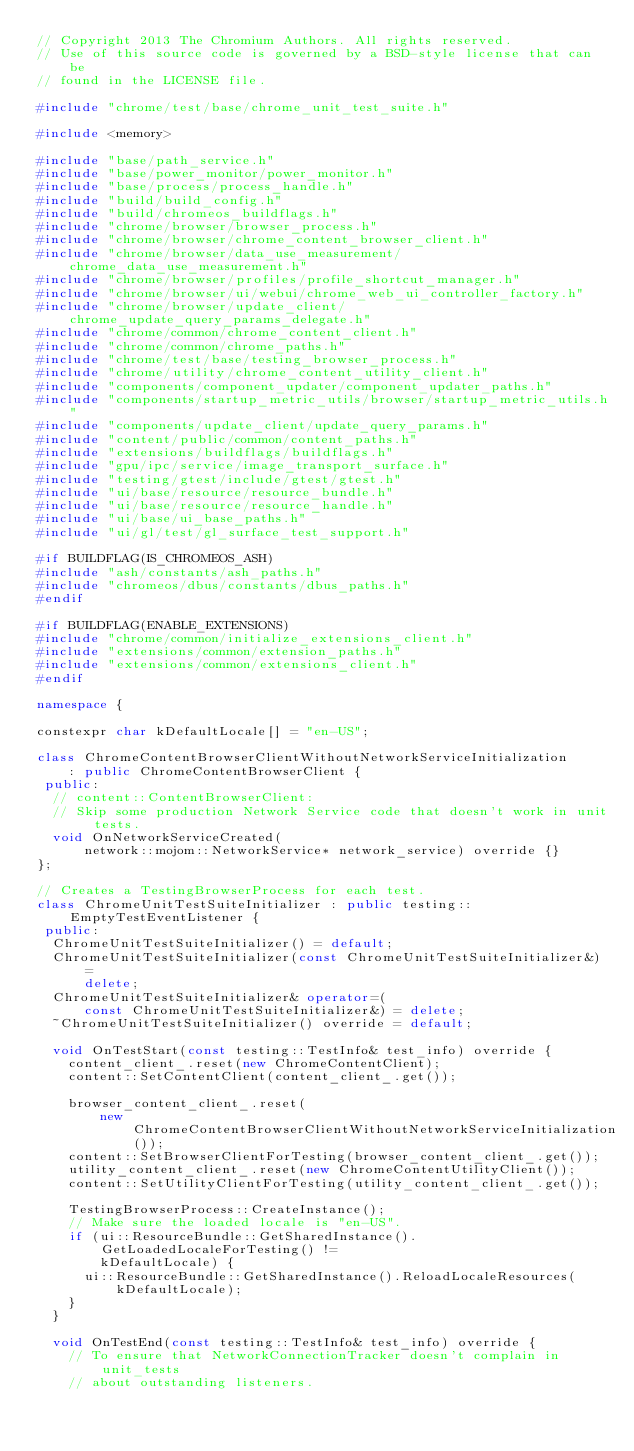Convert code to text. <code><loc_0><loc_0><loc_500><loc_500><_C++_>// Copyright 2013 The Chromium Authors. All rights reserved.
// Use of this source code is governed by a BSD-style license that can be
// found in the LICENSE file.

#include "chrome/test/base/chrome_unit_test_suite.h"

#include <memory>

#include "base/path_service.h"
#include "base/power_monitor/power_monitor.h"
#include "base/process/process_handle.h"
#include "build/build_config.h"
#include "build/chromeos_buildflags.h"
#include "chrome/browser/browser_process.h"
#include "chrome/browser/chrome_content_browser_client.h"
#include "chrome/browser/data_use_measurement/chrome_data_use_measurement.h"
#include "chrome/browser/profiles/profile_shortcut_manager.h"
#include "chrome/browser/ui/webui/chrome_web_ui_controller_factory.h"
#include "chrome/browser/update_client/chrome_update_query_params_delegate.h"
#include "chrome/common/chrome_content_client.h"
#include "chrome/common/chrome_paths.h"
#include "chrome/test/base/testing_browser_process.h"
#include "chrome/utility/chrome_content_utility_client.h"
#include "components/component_updater/component_updater_paths.h"
#include "components/startup_metric_utils/browser/startup_metric_utils.h"
#include "components/update_client/update_query_params.h"
#include "content/public/common/content_paths.h"
#include "extensions/buildflags/buildflags.h"
#include "gpu/ipc/service/image_transport_surface.h"
#include "testing/gtest/include/gtest/gtest.h"
#include "ui/base/resource/resource_bundle.h"
#include "ui/base/resource/resource_handle.h"
#include "ui/base/ui_base_paths.h"
#include "ui/gl/test/gl_surface_test_support.h"

#if BUILDFLAG(IS_CHROMEOS_ASH)
#include "ash/constants/ash_paths.h"
#include "chromeos/dbus/constants/dbus_paths.h"
#endif

#if BUILDFLAG(ENABLE_EXTENSIONS)
#include "chrome/common/initialize_extensions_client.h"
#include "extensions/common/extension_paths.h"
#include "extensions/common/extensions_client.h"
#endif

namespace {

constexpr char kDefaultLocale[] = "en-US";

class ChromeContentBrowserClientWithoutNetworkServiceInitialization
    : public ChromeContentBrowserClient {
 public:
  // content::ContentBrowserClient:
  // Skip some production Network Service code that doesn't work in unit tests.
  void OnNetworkServiceCreated(
      network::mojom::NetworkService* network_service) override {}
};

// Creates a TestingBrowserProcess for each test.
class ChromeUnitTestSuiteInitializer : public testing::EmptyTestEventListener {
 public:
  ChromeUnitTestSuiteInitializer() = default;
  ChromeUnitTestSuiteInitializer(const ChromeUnitTestSuiteInitializer&) =
      delete;
  ChromeUnitTestSuiteInitializer& operator=(
      const ChromeUnitTestSuiteInitializer&) = delete;
  ~ChromeUnitTestSuiteInitializer() override = default;

  void OnTestStart(const testing::TestInfo& test_info) override {
    content_client_.reset(new ChromeContentClient);
    content::SetContentClient(content_client_.get());

    browser_content_client_.reset(
        new ChromeContentBrowserClientWithoutNetworkServiceInitialization());
    content::SetBrowserClientForTesting(browser_content_client_.get());
    utility_content_client_.reset(new ChromeContentUtilityClient());
    content::SetUtilityClientForTesting(utility_content_client_.get());

    TestingBrowserProcess::CreateInstance();
    // Make sure the loaded locale is "en-US".
    if (ui::ResourceBundle::GetSharedInstance().GetLoadedLocaleForTesting() !=
        kDefaultLocale) {
      ui::ResourceBundle::GetSharedInstance().ReloadLocaleResources(
          kDefaultLocale);
    }
  }

  void OnTestEnd(const testing::TestInfo& test_info) override {
    // To ensure that NetworkConnectionTracker doesn't complain in unit_tests
    // about outstanding listeners.</code> 